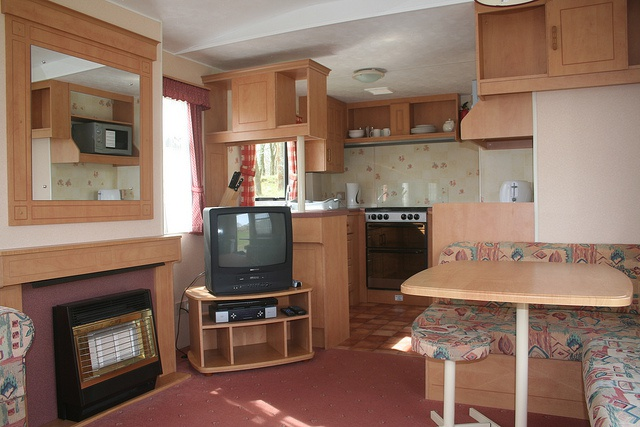Describe the objects in this image and their specific colors. I can see couch in olive, brown, gray, and darkgray tones, dining table in olive and tan tones, tv in olive, gray, black, darkgray, and purple tones, oven in olive, black, darkgray, gray, and maroon tones, and refrigerator in olive, darkgray, gray, and tan tones in this image. 